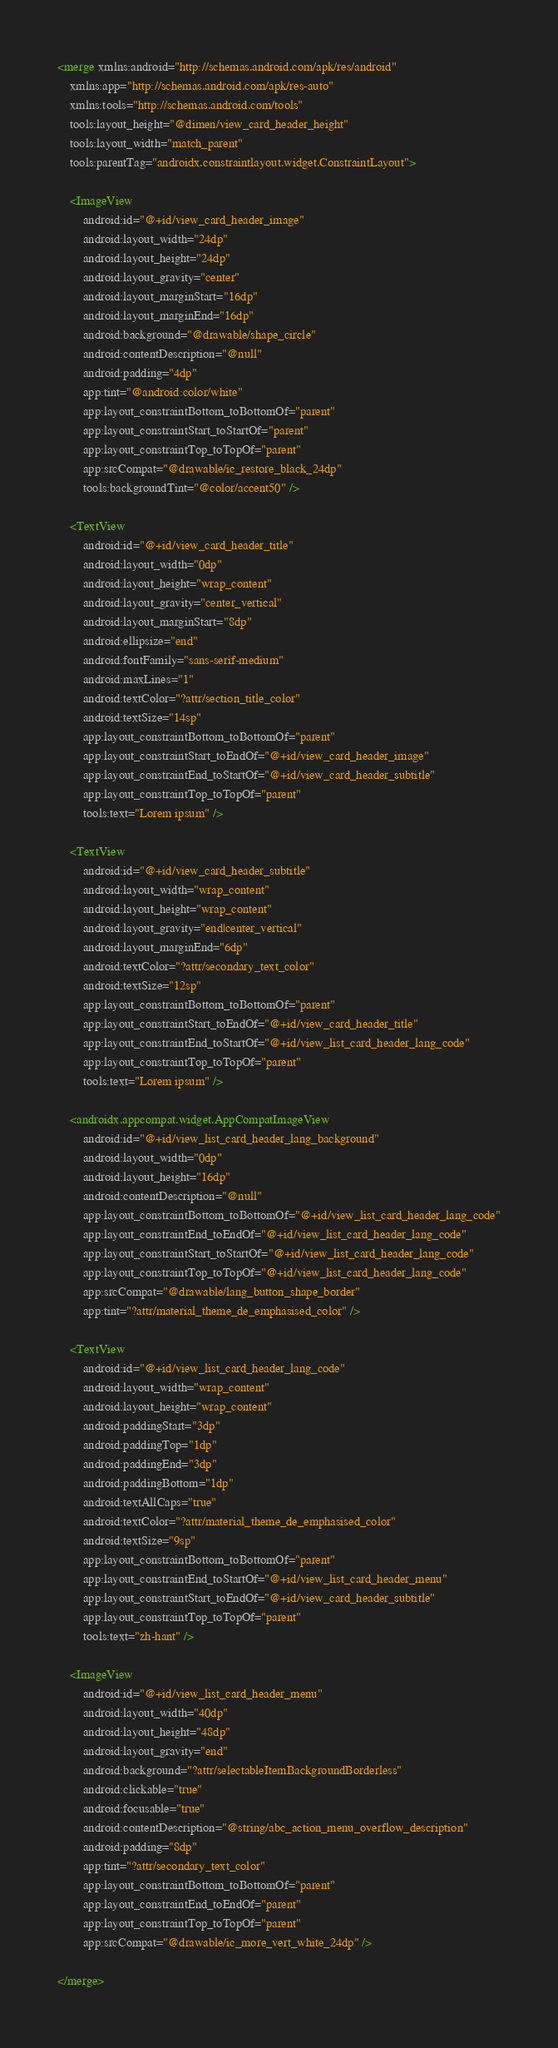<code> <loc_0><loc_0><loc_500><loc_500><_XML_><merge xmlns:android="http://schemas.android.com/apk/res/android"
    xmlns:app="http://schemas.android.com/apk/res-auto"
    xmlns:tools="http://schemas.android.com/tools"
    tools:layout_height="@dimen/view_card_header_height"
    tools:layout_width="match_parent"
    tools:parentTag="androidx.constraintlayout.widget.ConstraintLayout">

    <ImageView
        android:id="@+id/view_card_header_image"
        android:layout_width="24dp"
        android:layout_height="24dp"
        android:layout_gravity="center"
        android:layout_marginStart="16dp"
        android:layout_marginEnd="16dp"
        android:background="@drawable/shape_circle"
        android:contentDescription="@null"
        android:padding="4dp"
        app:tint="@android:color/white"
        app:layout_constraintBottom_toBottomOf="parent"
        app:layout_constraintStart_toStartOf="parent"
        app:layout_constraintTop_toTopOf="parent"
        app:srcCompat="@drawable/ic_restore_black_24dp"
        tools:backgroundTint="@color/accent50" />

    <TextView
        android:id="@+id/view_card_header_title"
        android:layout_width="0dp"
        android:layout_height="wrap_content"
        android:layout_gravity="center_vertical"
        android:layout_marginStart="8dp"
        android:ellipsize="end"
        android:fontFamily="sans-serif-medium"
        android:maxLines="1"
        android:textColor="?attr/section_title_color"
        android:textSize="14sp"
        app:layout_constraintBottom_toBottomOf="parent"
        app:layout_constraintStart_toEndOf="@+id/view_card_header_image"
        app:layout_constraintEnd_toStartOf="@+id/view_card_header_subtitle"
        app:layout_constraintTop_toTopOf="parent"
        tools:text="Lorem ipsum" />

    <TextView
        android:id="@+id/view_card_header_subtitle"
        android:layout_width="wrap_content"
        android:layout_height="wrap_content"
        android:layout_gravity="end|center_vertical"
        android:layout_marginEnd="6dp"
        android:textColor="?attr/secondary_text_color"
        android:textSize="12sp"
        app:layout_constraintBottom_toBottomOf="parent"
        app:layout_constraintStart_toEndOf="@+id/view_card_header_title"
        app:layout_constraintEnd_toStartOf="@+id/view_list_card_header_lang_code"
        app:layout_constraintTop_toTopOf="parent"
        tools:text="Lorem ipsum" />

    <androidx.appcompat.widget.AppCompatImageView
        android:id="@+id/view_list_card_header_lang_background"
        android:layout_width="0dp"
        android:layout_height="16dp"
        android:contentDescription="@null"
        app:layout_constraintBottom_toBottomOf="@+id/view_list_card_header_lang_code"
        app:layout_constraintEnd_toEndOf="@+id/view_list_card_header_lang_code"
        app:layout_constraintStart_toStartOf="@+id/view_list_card_header_lang_code"
        app:layout_constraintTop_toTopOf="@+id/view_list_card_header_lang_code"
        app:srcCompat="@drawable/lang_button_shape_border"
        app:tint="?attr/material_theme_de_emphasised_color" />

    <TextView
        android:id="@+id/view_list_card_header_lang_code"
        android:layout_width="wrap_content"
        android:layout_height="wrap_content"
        android:paddingStart="3dp"
        android:paddingTop="1dp"
        android:paddingEnd="3dp"
        android:paddingBottom="1dp"
        android:textAllCaps="true"
        android:textColor="?attr/material_theme_de_emphasised_color"
        android:textSize="9sp"
        app:layout_constraintBottom_toBottomOf="parent"
        app:layout_constraintEnd_toStartOf="@+id/view_list_card_header_menu"
        app:layout_constraintStart_toEndOf="@+id/view_card_header_subtitle"
        app:layout_constraintTop_toTopOf="parent"
        tools:text="zh-hant" />

    <ImageView
        android:id="@+id/view_list_card_header_menu"
        android:layout_width="40dp"
        android:layout_height="48dp"
        android:layout_gravity="end"
        android:background="?attr/selectableItemBackgroundBorderless"
        android:clickable="true"
        android:focusable="true"
        android:contentDescription="@string/abc_action_menu_overflow_description"
        android:padding="8dp"
        app:tint="?attr/secondary_text_color"
        app:layout_constraintBottom_toBottomOf="parent"
        app:layout_constraintEnd_toEndOf="parent"
        app:layout_constraintTop_toTopOf="parent"
        app:srcCompat="@drawable/ic_more_vert_white_24dp" />

</merge></code> 